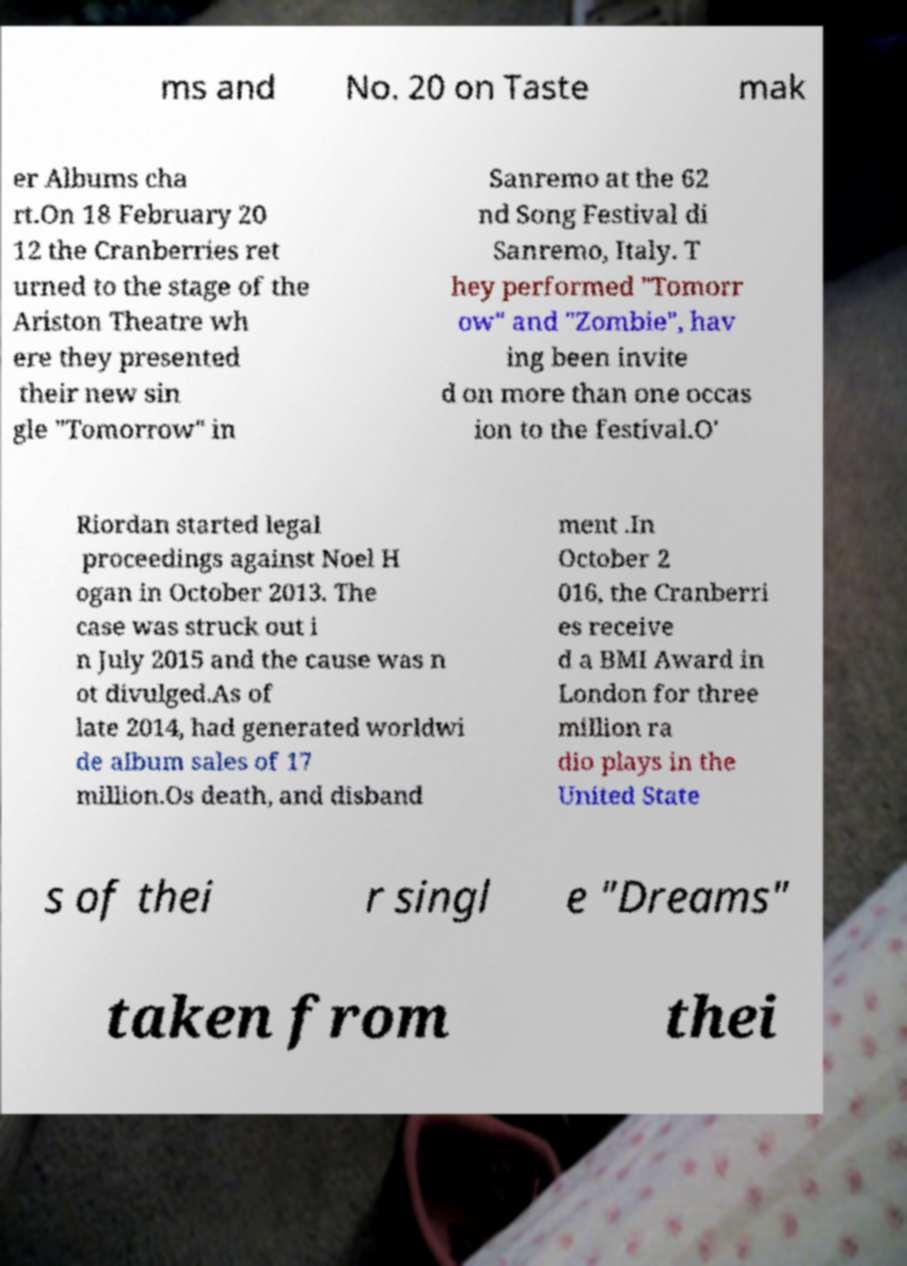I need the written content from this picture converted into text. Can you do that? ms and No. 20 on Taste mak er Albums cha rt.On 18 February 20 12 the Cranberries ret urned to the stage of the Ariston Theatre wh ere they presented their new sin gle "Tomorrow" in Sanremo at the 62 nd Song Festival di Sanremo, Italy. T hey performed "Tomorr ow" and "Zombie", hav ing been invite d on more than one occas ion to the festival.O' Riordan started legal proceedings against Noel H ogan in October 2013. The case was struck out i n July 2015 and the cause was n ot divulged.As of late 2014, had generated worldwi de album sales of 17 million.Os death, and disband ment .In October 2 016, the Cranberri es receive d a BMI Award in London for three million ra dio plays in the United State s of thei r singl e "Dreams" taken from thei 